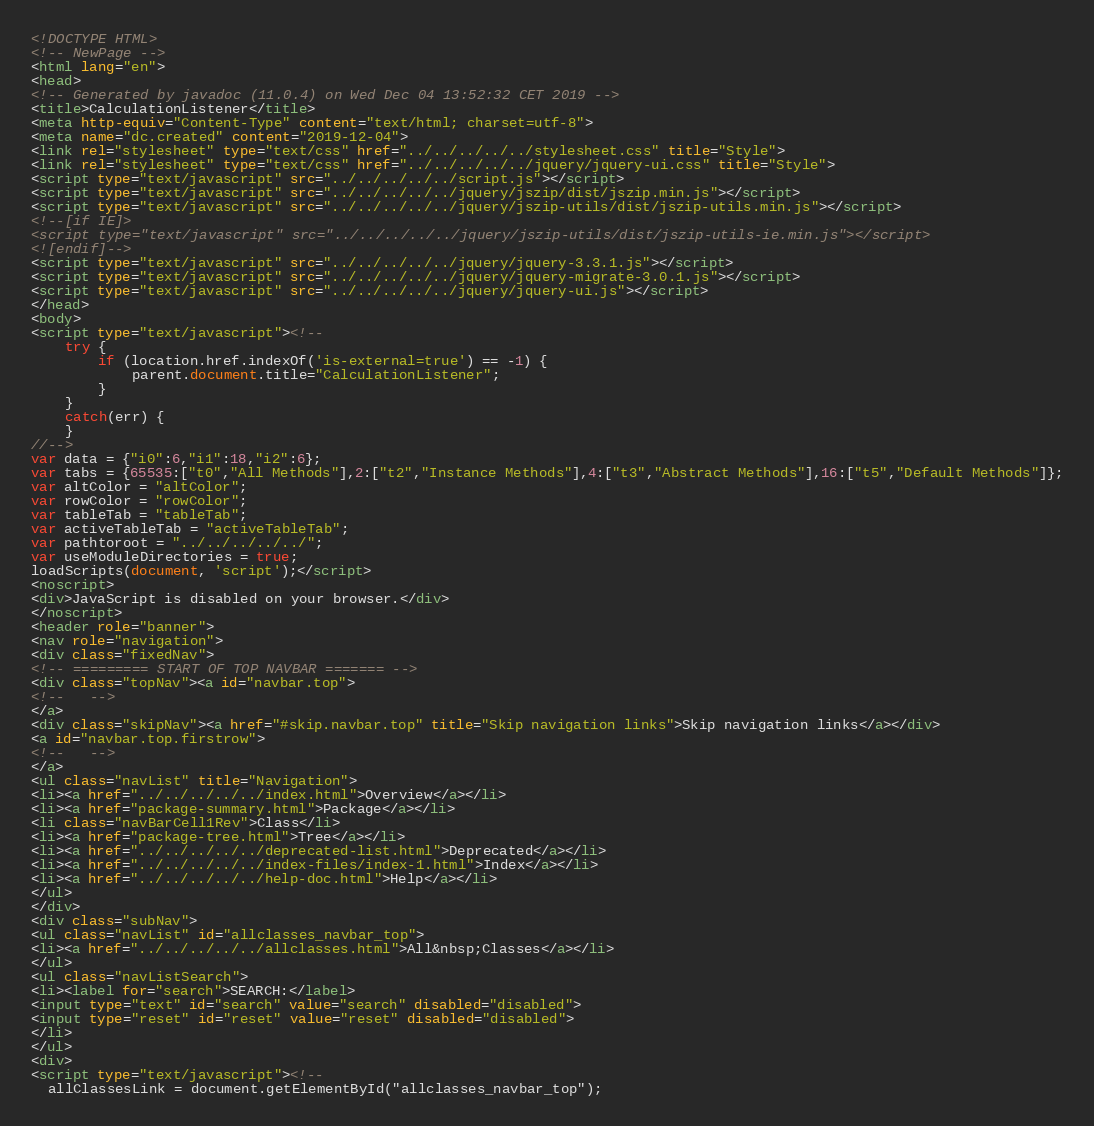Convert code to text. <code><loc_0><loc_0><loc_500><loc_500><_HTML_><!DOCTYPE HTML>
<!-- NewPage -->
<html lang="en">
<head>
<!-- Generated by javadoc (11.0.4) on Wed Dec 04 13:52:32 CET 2019 -->
<title>CalculationListener</title>
<meta http-equiv="Content-Type" content="text/html; charset=utf-8">
<meta name="dc.created" content="2019-12-04">
<link rel="stylesheet" type="text/css" href="../../../../../stylesheet.css" title="Style">
<link rel="stylesheet" type="text/css" href="../../../../../jquery/jquery-ui.css" title="Style">
<script type="text/javascript" src="../../../../../script.js"></script>
<script type="text/javascript" src="../../../../../jquery/jszip/dist/jszip.min.js"></script>
<script type="text/javascript" src="../../../../../jquery/jszip-utils/dist/jszip-utils.min.js"></script>
<!--[if IE]>
<script type="text/javascript" src="../../../../../jquery/jszip-utils/dist/jszip-utils-ie.min.js"></script>
<![endif]-->
<script type="text/javascript" src="../../../../../jquery/jquery-3.3.1.js"></script>
<script type="text/javascript" src="../../../../../jquery/jquery-migrate-3.0.1.js"></script>
<script type="text/javascript" src="../../../../../jquery/jquery-ui.js"></script>
</head>
<body>
<script type="text/javascript"><!--
    try {
        if (location.href.indexOf('is-external=true') == -1) {
            parent.document.title="CalculationListener";
        }
    }
    catch(err) {
    }
//-->
var data = {"i0":6,"i1":18,"i2":6};
var tabs = {65535:["t0","All Methods"],2:["t2","Instance Methods"],4:["t3","Abstract Methods"],16:["t5","Default Methods"]};
var altColor = "altColor";
var rowColor = "rowColor";
var tableTab = "tableTab";
var activeTableTab = "activeTableTab";
var pathtoroot = "../../../../../";
var useModuleDirectories = true;
loadScripts(document, 'script');</script>
<noscript>
<div>JavaScript is disabled on your browser.</div>
</noscript>
<header role="banner">
<nav role="navigation">
<div class="fixedNav">
<!-- ========= START OF TOP NAVBAR ======= -->
<div class="topNav"><a id="navbar.top">
<!--   -->
</a>
<div class="skipNav"><a href="#skip.navbar.top" title="Skip navigation links">Skip navigation links</a></div>
<a id="navbar.top.firstrow">
<!--   -->
</a>
<ul class="navList" title="Navigation">
<li><a href="../../../../../index.html">Overview</a></li>
<li><a href="package-summary.html">Package</a></li>
<li class="navBarCell1Rev">Class</li>
<li><a href="package-tree.html">Tree</a></li>
<li><a href="../../../../../deprecated-list.html">Deprecated</a></li>
<li><a href="../../../../../index-files/index-1.html">Index</a></li>
<li><a href="../../../../../help-doc.html">Help</a></li>
</ul>
</div>
<div class="subNav">
<ul class="navList" id="allclasses_navbar_top">
<li><a href="../../../../../allclasses.html">All&nbsp;Classes</a></li>
</ul>
<ul class="navListSearch">
<li><label for="search">SEARCH:</label>
<input type="text" id="search" value="search" disabled="disabled">
<input type="reset" id="reset" value="reset" disabled="disabled">
</li>
</ul>
<div>
<script type="text/javascript"><!--
  allClassesLink = document.getElementById("allclasses_navbar_top");</code> 